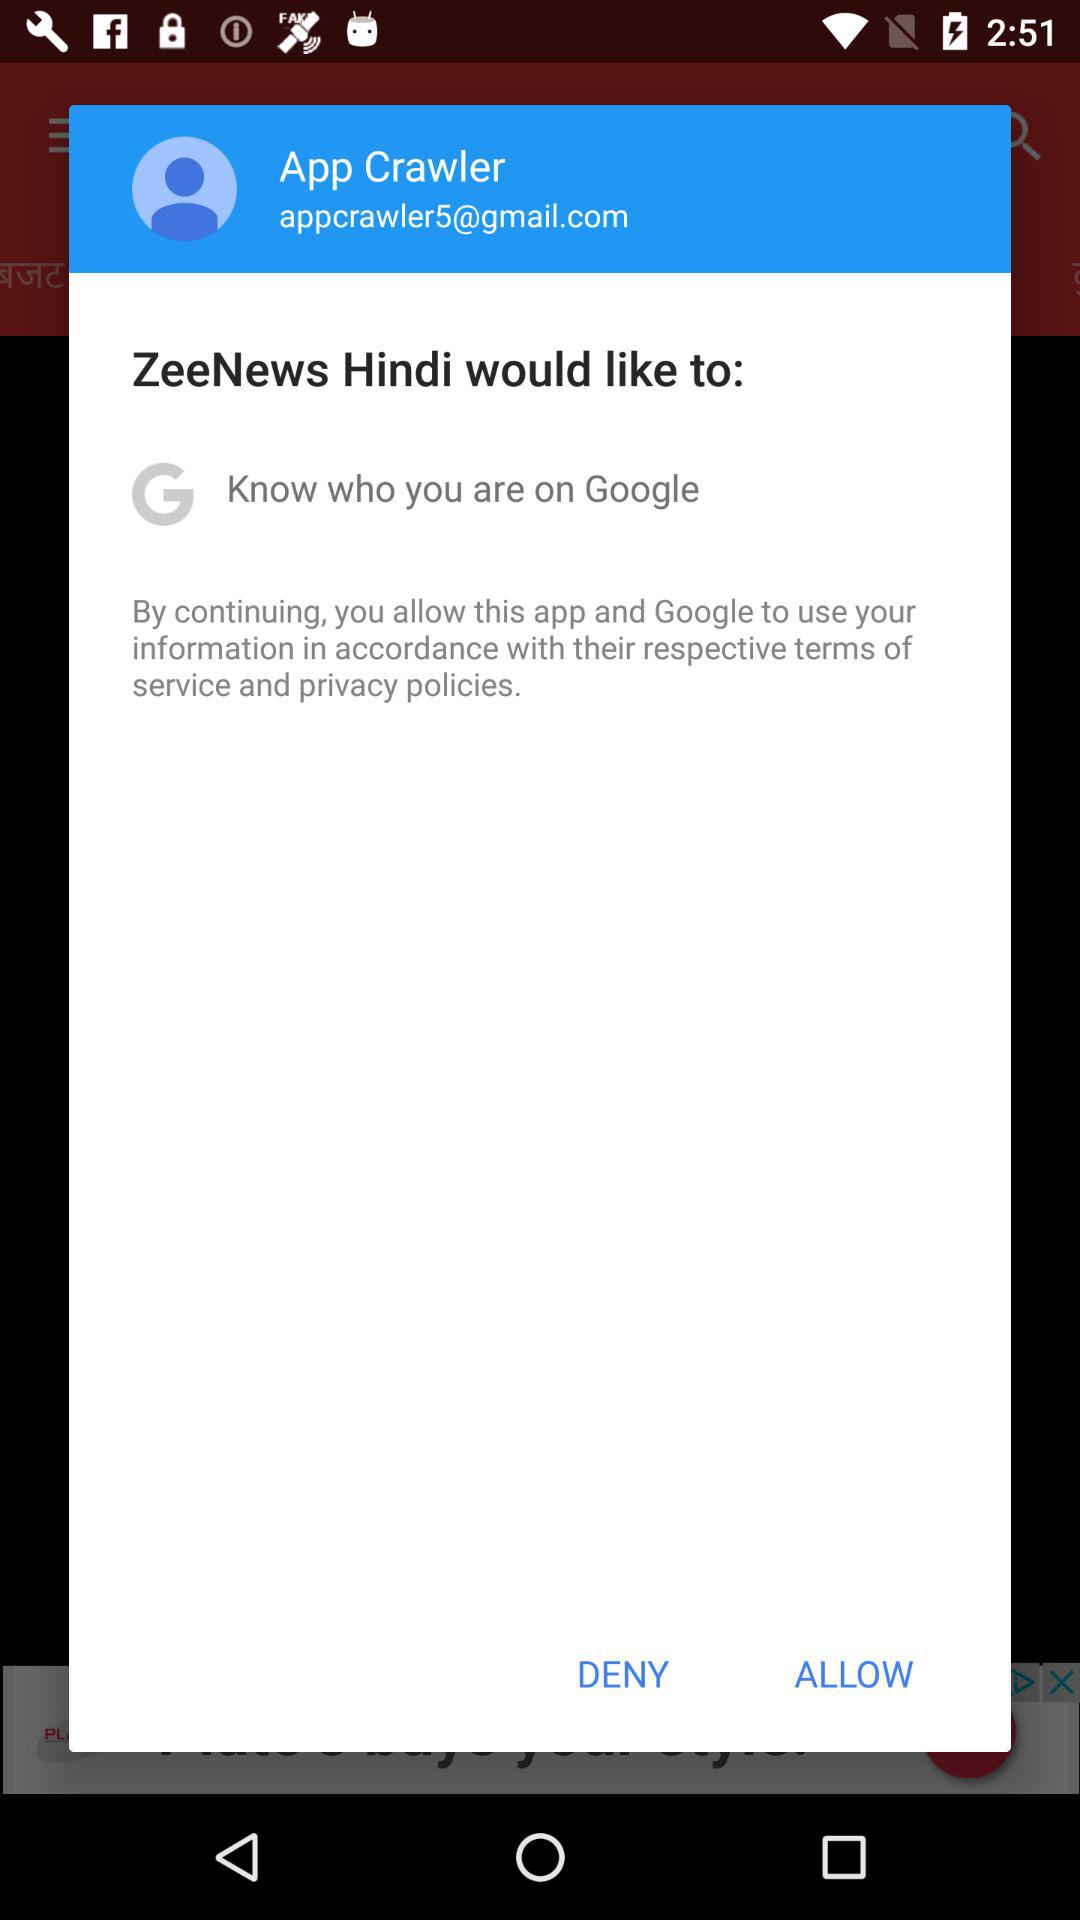What information would Zee News Hindi like to know? ZeeNews Hindi would like to know who you are on Google. 